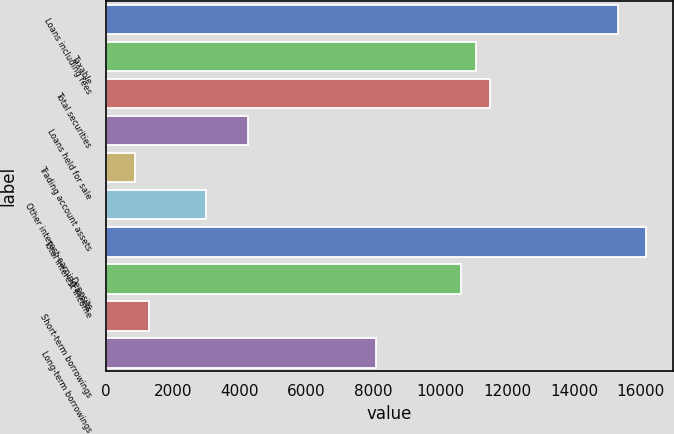Convert chart to OTSL. <chart><loc_0><loc_0><loc_500><loc_500><bar_chart><fcel>Loans including fees<fcel>Taxable<fcel>Total securities<fcel>Loans held for sale<fcel>Trading account assets<fcel>Other interest-earning assets<fcel>Total interest income<fcel>Deposits<fcel>Short-term borrowings<fcel>Long-term borrowings<nl><fcel>15307.2<fcel>11055.2<fcel>11480.4<fcel>4252.02<fcel>850.42<fcel>2976.42<fcel>16157.6<fcel>10630<fcel>1275.62<fcel>8078.82<nl></chart> 